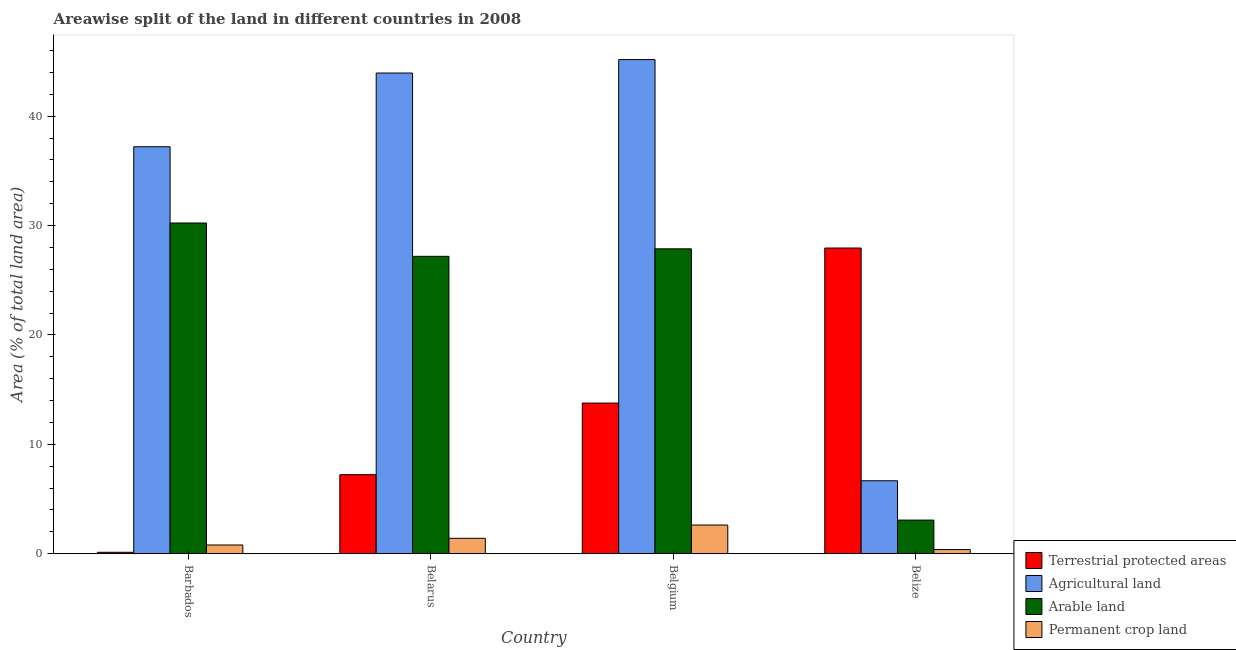How many groups of bars are there?
Ensure brevity in your answer.  4. How many bars are there on the 2nd tick from the left?
Ensure brevity in your answer.  4. How many bars are there on the 3rd tick from the right?
Provide a succinct answer. 4. What is the label of the 2nd group of bars from the left?
Provide a short and direct response. Belarus. What is the percentage of area under permanent crop land in Belize?
Offer a very short reply. 0.38. Across all countries, what is the maximum percentage of land under terrestrial protection?
Keep it short and to the point. 27.95. Across all countries, what is the minimum percentage of land under terrestrial protection?
Ensure brevity in your answer.  0.12. In which country was the percentage of area under arable land maximum?
Your answer should be compact. Barbados. In which country was the percentage of area under agricultural land minimum?
Your answer should be compact. Belize. What is the total percentage of land under terrestrial protection in the graph?
Provide a succinct answer. 49.06. What is the difference between the percentage of area under agricultural land in Belarus and that in Belize?
Provide a succinct answer. 37.28. What is the difference between the percentage of area under agricultural land in Belarus and the percentage of area under permanent crop land in Belgium?
Keep it short and to the point. 41.33. What is the average percentage of area under arable land per country?
Keep it short and to the point. 22.09. What is the difference between the percentage of area under arable land and percentage of land under terrestrial protection in Belarus?
Make the answer very short. 19.96. What is the ratio of the percentage of area under arable land in Belgium to that in Belize?
Your answer should be very brief. 9.08. What is the difference between the highest and the second highest percentage of area under agricultural land?
Provide a short and direct response. 1.23. What is the difference between the highest and the lowest percentage of area under arable land?
Keep it short and to the point. 27.16. In how many countries, is the percentage of area under agricultural land greater than the average percentage of area under agricultural land taken over all countries?
Offer a terse response. 3. Is the sum of the percentage of area under arable land in Belgium and Belize greater than the maximum percentage of land under terrestrial protection across all countries?
Your answer should be compact. Yes. What does the 3rd bar from the left in Barbados represents?
Provide a succinct answer. Arable land. What does the 3rd bar from the right in Belize represents?
Your answer should be very brief. Agricultural land. Is it the case that in every country, the sum of the percentage of land under terrestrial protection and percentage of area under agricultural land is greater than the percentage of area under arable land?
Provide a short and direct response. Yes. Are all the bars in the graph horizontal?
Ensure brevity in your answer.  No. How many countries are there in the graph?
Give a very brief answer. 4. What is the difference between two consecutive major ticks on the Y-axis?
Offer a very short reply. 10. Does the graph contain any zero values?
Offer a very short reply. No. Does the graph contain grids?
Provide a succinct answer. No. Where does the legend appear in the graph?
Keep it short and to the point. Bottom right. How many legend labels are there?
Offer a terse response. 4. What is the title of the graph?
Provide a succinct answer. Areawise split of the land in different countries in 2008. Does "Minerals" appear as one of the legend labels in the graph?
Provide a succinct answer. No. What is the label or title of the X-axis?
Keep it short and to the point. Country. What is the label or title of the Y-axis?
Offer a terse response. Area (% of total land area). What is the Area (% of total land area) in Terrestrial protected areas in Barbados?
Your answer should be very brief. 0.12. What is the Area (% of total land area) in Agricultural land in Barbados?
Provide a succinct answer. 37.21. What is the Area (% of total land area) of Arable land in Barbados?
Give a very brief answer. 30.23. What is the Area (% of total land area) in Permanent crop land in Barbados?
Provide a short and direct response. 0.79. What is the Area (% of total land area) in Terrestrial protected areas in Belarus?
Ensure brevity in your answer.  7.22. What is the Area (% of total land area) in Agricultural land in Belarus?
Give a very brief answer. 43.95. What is the Area (% of total land area) in Arable land in Belarus?
Keep it short and to the point. 27.19. What is the Area (% of total land area) of Permanent crop land in Belarus?
Provide a succinct answer. 1.4. What is the Area (% of total land area) in Terrestrial protected areas in Belgium?
Provide a succinct answer. 13.77. What is the Area (% of total land area) of Agricultural land in Belgium?
Make the answer very short. 45.18. What is the Area (% of total land area) in Arable land in Belgium?
Provide a short and direct response. 27.87. What is the Area (% of total land area) of Permanent crop land in Belgium?
Provide a succinct answer. 2.62. What is the Area (% of total land area) of Terrestrial protected areas in Belize?
Offer a very short reply. 27.95. What is the Area (% of total land area) in Agricultural land in Belize?
Ensure brevity in your answer.  6.66. What is the Area (% of total land area) of Arable land in Belize?
Keep it short and to the point. 3.07. What is the Area (% of total land area) in Permanent crop land in Belize?
Your answer should be compact. 0.38. Across all countries, what is the maximum Area (% of total land area) of Terrestrial protected areas?
Offer a very short reply. 27.95. Across all countries, what is the maximum Area (% of total land area) of Agricultural land?
Your answer should be compact. 45.18. Across all countries, what is the maximum Area (% of total land area) of Arable land?
Offer a terse response. 30.23. Across all countries, what is the maximum Area (% of total land area) in Permanent crop land?
Your response must be concise. 2.62. Across all countries, what is the minimum Area (% of total land area) of Terrestrial protected areas?
Provide a succinct answer. 0.12. Across all countries, what is the minimum Area (% of total land area) in Agricultural land?
Offer a terse response. 6.66. Across all countries, what is the minimum Area (% of total land area) in Arable land?
Offer a very short reply. 3.07. Across all countries, what is the minimum Area (% of total land area) in Permanent crop land?
Provide a succinct answer. 0.38. What is the total Area (% of total land area) of Terrestrial protected areas in the graph?
Your answer should be compact. 49.06. What is the total Area (% of total land area) of Agricultural land in the graph?
Your answer should be very brief. 133. What is the total Area (% of total land area) in Arable land in the graph?
Your response must be concise. 88.36. What is the total Area (% of total land area) of Permanent crop land in the graph?
Offer a terse response. 5.19. What is the difference between the Area (% of total land area) in Terrestrial protected areas in Barbados and that in Belarus?
Your answer should be compact. -7.1. What is the difference between the Area (% of total land area) in Agricultural land in Barbados and that in Belarus?
Offer a terse response. -6.74. What is the difference between the Area (% of total land area) of Arable land in Barbados and that in Belarus?
Your answer should be compact. 3.05. What is the difference between the Area (% of total land area) of Permanent crop land in Barbados and that in Belarus?
Your answer should be very brief. -0.61. What is the difference between the Area (% of total land area) of Terrestrial protected areas in Barbados and that in Belgium?
Your answer should be compact. -13.65. What is the difference between the Area (% of total land area) of Agricultural land in Barbados and that in Belgium?
Your answer should be very brief. -7.97. What is the difference between the Area (% of total land area) of Arable land in Barbados and that in Belgium?
Offer a very short reply. 2.36. What is the difference between the Area (% of total land area) in Permanent crop land in Barbados and that in Belgium?
Provide a short and direct response. -1.82. What is the difference between the Area (% of total land area) of Terrestrial protected areas in Barbados and that in Belize?
Keep it short and to the point. -27.82. What is the difference between the Area (% of total land area) of Agricultural land in Barbados and that in Belize?
Provide a succinct answer. 30.55. What is the difference between the Area (% of total land area) in Arable land in Barbados and that in Belize?
Keep it short and to the point. 27.16. What is the difference between the Area (% of total land area) of Permanent crop land in Barbados and that in Belize?
Your answer should be very brief. 0.42. What is the difference between the Area (% of total land area) of Terrestrial protected areas in Belarus and that in Belgium?
Keep it short and to the point. -6.55. What is the difference between the Area (% of total land area) of Agricultural land in Belarus and that in Belgium?
Your answer should be very brief. -1.23. What is the difference between the Area (% of total land area) of Arable land in Belarus and that in Belgium?
Your answer should be compact. -0.69. What is the difference between the Area (% of total land area) in Permanent crop land in Belarus and that in Belgium?
Offer a terse response. -1.21. What is the difference between the Area (% of total land area) of Terrestrial protected areas in Belarus and that in Belize?
Offer a very short reply. -20.72. What is the difference between the Area (% of total land area) in Agricultural land in Belarus and that in Belize?
Keep it short and to the point. 37.28. What is the difference between the Area (% of total land area) of Arable land in Belarus and that in Belize?
Your answer should be very brief. 24.12. What is the difference between the Area (% of total land area) in Permanent crop land in Belarus and that in Belize?
Make the answer very short. 1.03. What is the difference between the Area (% of total land area) of Terrestrial protected areas in Belgium and that in Belize?
Give a very brief answer. -14.18. What is the difference between the Area (% of total land area) in Agricultural land in Belgium and that in Belize?
Make the answer very short. 38.51. What is the difference between the Area (% of total land area) of Arable land in Belgium and that in Belize?
Provide a short and direct response. 24.8. What is the difference between the Area (% of total land area) in Permanent crop land in Belgium and that in Belize?
Provide a short and direct response. 2.24. What is the difference between the Area (% of total land area) in Terrestrial protected areas in Barbados and the Area (% of total land area) in Agricultural land in Belarus?
Offer a very short reply. -43.82. What is the difference between the Area (% of total land area) of Terrestrial protected areas in Barbados and the Area (% of total land area) of Arable land in Belarus?
Make the answer very short. -27.06. What is the difference between the Area (% of total land area) of Terrestrial protected areas in Barbados and the Area (% of total land area) of Permanent crop land in Belarus?
Make the answer very short. -1.28. What is the difference between the Area (% of total land area) in Agricultural land in Barbados and the Area (% of total land area) in Arable land in Belarus?
Make the answer very short. 10.02. What is the difference between the Area (% of total land area) of Agricultural land in Barbados and the Area (% of total land area) of Permanent crop land in Belarus?
Keep it short and to the point. 35.81. What is the difference between the Area (% of total land area) in Arable land in Barbados and the Area (% of total land area) in Permanent crop land in Belarus?
Offer a very short reply. 28.83. What is the difference between the Area (% of total land area) in Terrestrial protected areas in Barbados and the Area (% of total land area) in Agricultural land in Belgium?
Make the answer very short. -45.05. What is the difference between the Area (% of total land area) of Terrestrial protected areas in Barbados and the Area (% of total land area) of Arable land in Belgium?
Give a very brief answer. -27.75. What is the difference between the Area (% of total land area) in Terrestrial protected areas in Barbados and the Area (% of total land area) in Permanent crop land in Belgium?
Your response must be concise. -2.49. What is the difference between the Area (% of total land area) in Agricultural land in Barbados and the Area (% of total land area) in Arable land in Belgium?
Provide a succinct answer. 9.34. What is the difference between the Area (% of total land area) in Agricultural land in Barbados and the Area (% of total land area) in Permanent crop land in Belgium?
Provide a short and direct response. 34.59. What is the difference between the Area (% of total land area) of Arable land in Barbados and the Area (% of total land area) of Permanent crop land in Belgium?
Offer a very short reply. 27.62. What is the difference between the Area (% of total land area) in Terrestrial protected areas in Barbados and the Area (% of total land area) in Agricultural land in Belize?
Make the answer very short. -6.54. What is the difference between the Area (% of total land area) of Terrestrial protected areas in Barbados and the Area (% of total land area) of Arable land in Belize?
Offer a terse response. -2.94. What is the difference between the Area (% of total land area) of Terrestrial protected areas in Barbados and the Area (% of total land area) of Permanent crop land in Belize?
Your answer should be compact. -0.25. What is the difference between the Area (% of total land area) of Agricultural land in Barbados and the Area (% of total land area) of Arable land in Belize?
Give a very brief answer. 34.14. What is the difference between the Area (% of total land area) of Agricultural land in Barbados and the Area (% of total land area) of Permanent crop land in Belize?
Offer a terse response. 36.83. What is the difference between the Area (% of total land area) in Arable land in Barbados and the Area (% of total land area) in Permanent crop land in Belize?
Ensure brevity in your answer.  29.86. What is the difference between the Area (% of total land area) of Terrestrial protected areas in Belarus and the Area (% of total land area) of Agricultural land in Belgium?
Offer a terse response. -37.96. What is the difference between the Area (% of total land area) in Terrestrial protected areas in Belarus and the Area (% of total land area) in Arable land in Belgium?
Provide a succinct answer. -20.65. What is the difference between the Area (% of total land area) of Terrestrial protected areas in Belarus and the Area (% of total land area) of Permanent crop land in Belgium?
Give a very brief answer. 4.61. What is the difference between the Area (% of total land area) in Agricultural land in Belarus and the Area (% of total land area) in Arable land in Belgium?
Offer a terse response. 16.07. What is the difference between the Area (% of total land area) of Agricultural land in Belarus and the Area (% of total land area) of Permanent crop land in Belgium?
Offer a terse response. 41.33. What is the difference between the Area (% of total land area) of Arable land in Belarus and the Area (% of total land area) of Permanent crop land in Belgium?
Ensure brevity in your answer.  24.57. What is the difference between the Area (% of total land area) of Terrestrial protected areas in Belarus and the Area (% of total land area) of Agricultural land in Belize?
Keep it short and to the point. 0.56. What is the difference between the Area (% of total land area) of Terrestrial protected areas in Belarus and the Area (% of total land area) of Arable land in Belize?
Ensure brevity in your answer.  4.15. What is the difference between the Area (% of total land area) of Terrestrial protected areas in Belarus and the Area (% of total land area) of Permanent crop land in Belize?
Offer a terse response. 6.85. What is the difference between the Area (% of total land area) in Agricultural land in Belarus and the Area (% of total land area) in Arable land in Belize?
Keep it short and to the point. 40.88. What is the difference between the Area (% of total land area) of Agricultural land in Belarus and the Area (% of total land area) of Permanent crop land in Belize?
Your answer should be very brief. 43.57. What is the difference between the Area (% of total land area) of Arable land in Belarus and the Area (% of total land area) of Permanent crop land in Belize?
Keep it short and to the point. 26.81. What is the difference between the Area (% of total land area) in Terrestrial protected areas in Belgium and the Area (% of total land area) in Agricultural land in Belize?
Ensure brevity in your answer.  7.11. What is the difference between the Area (% of total land area) in Terrestrial protected areas in Belgium and the Area (% of total land area) in Arable land in Belize?
Keep it short and to the point. 10.7. What is the difference between the Area (% of total land area) of Terrestrial protected areas in Belgium and the Area (% of total land area) of Permanent crop land in Belize?
Offer a very short reply. 13.39. What is the difference between the Area (% of total land area) of Agricultural land in Belgium and the Area (% of total land area) of Arable land in Belize?
Your response must be concise. 42.11. What is the difference between the Area (% of total land area) in Agricultural land in Belgium and the Area (% of total land area) in Permanent crop land in Belize?
Provide a short and direct response. 44.8. What is the difference between the Area (% of total land area) in Arable land in Belgium and the Area (% of total land area) in Permanent crop land in Belize?
Offer a very short reply. 27.5. What is the average Area (% of total land area) of Terrestrial protected areas per country?
Keep it short and to the point. 12.27. What is the average Area (% of total land area) of Agricultural land per country?
Ensure brevity in your answer.  33.25. What is the average Area (% of total land area) of Arable land per country?
Your answer should be compact. 22.09. What is the average Area (% of total land area) in Permanent crop land per country?
Keep it short and to the point. 1.3. What is the difference between the Area (% of total land area) in Terrestrial protected areas and Area (% of total land area) in Agricultural land in Barbados?
Your answer should be very brief. -37.09. What is the difference between the Area (% of total land area) in Terrestrial protected areas and Area (% of total land area) in Arable land in Barbados?
Provide a short and direct response. -30.11. What is the difference between the Area (% of total land area) in Terrestrial protected areas and Area (% of total land area) in Permanent crop land in Barbados?
Make the answer very short. -0.67. What is the difference between the Area (% of total land area) of Agricultural land and Area (% of total land area) of Arable land in Barbados?
Provide a succinct answer. 6.98. What is the difference between the Area (% of total land area) in Agricultural land and Area (% of total land area) in Permanent crop land in Barbados?
Keep it short and to the point. 36.42. What is the difference between the Area (% of total land area) of Arable land and Area (% of total land area) of Permanent crop land in Barbados?
Offer a terse response. 29.44. What is the difference between the Area (% of total land area) in Terrestrial protected areas and Area (% of total land area) in Agricultural land in Belarus?
Provide a short and direct response. -36.73. What is the difference between the Area (% of total land area) in Terrestrial protected areas and Area (% of total land area) in Arable land in Belarus?
Provide a succinct answer. -19.96. What is the difference between the Area (% of total land area) in Terrestrial protected areas and Area (% of total land area) in Permanent crop land in Belarus?
Keep it short and to the point. 5.82. What is the difference between the Area (% of total land area) of Agricultural land and Area (% of total land area) of Arable land in Belarus?
Provide a succinct answer. 16.76. What is the difference between the Area (% of total land area) in Agricultural land and Area (% of total land area) in Permanent crop land in Belarus?
Give a very brief answer. 42.54. What is the difference between the Area (% of total land area) of Arable land and Area (% of total land area) of Permanent crop land in Belarus?
Provide a short and direct response. 25.78. What is the difference between the Area (% of total land area) of Terrestrial protected areas and Area (% of total land area) of Agricultural land in Belgium?
Offer a very short reply. -31.41. What is the difference between the Area (% of total land area) of Terrestrial protected areas and Area (% of total land area) of Arable land in Belgium?
Provide a succinct answer. -14.1. What is the difference between the Area (% of total land area) in Terrestrial protected areas and Area (% of total land area) in Permanent crop land in Belgium?
Your answer should be very brief. 11.15. What is the difference between the Area (% of total land area) in Agricultural land and Area (% of total land area) in Arable land in Belgium?
Offer a very short reply. 17.31. What is the difference between the Area (% of total land area) in Agricultural land and Area (% of total land area) in Permanent crop land in Belgium?
Keep it short and to the point. 42.56. What is the difference between the Area (% of total land area) of Arable land and Area (% of total land area) of Permanent crop land in Belgium?
Your answer should be very brief. 25.26. What is the difference between the Area (% of total land area) in Terrestrial protected areas and Area (% of total land area) in Agricultural land in Belize?
Offer a very short reply. 21.28. What is the difference between the Area (% of total land area) in Terrestrial protected areas and Area (% of total land area) in Arable land in Belize?
Offer a terse response. 24.88. What is the difference between the Area (% of total land area) of Terrestrial protected areas and Area (% of total land area) of Permanent crop land in Belize?
Keep it short and to the point. 27.57. What is the difference between the Area (% of total land area) in Agricultural land and Area (% of total land area) in Arable land in Belize?
Make the answer very short. 3.59. What is the difference between the Area (% of total land area) in Agricultural land and Area (% of total land area) in Permanent crop land in Belize?
Offer a terse response. 6.29. What is the difference between the Area (% of total land area) in Arable land and Area (% of total land area) in Permanent crop land in Belize?
Ensure brevity in your answer.  2.69. What is the ratio of the Area (% of total land area) of Terrestrial protected areas in Barbados to that in Belarus?
Keep it short and to the point. 0.02. What is the ratio of the Area (% of total land area) in Agricultural land in Barbados to that in Belarus?
Provide a short and direct response. 0.85. What is the ratio of the Area (% of total land area) in Arable land in Barbados to that in Belarus?
Provide a short and direct response. 1.11. What is the ratio of the Area (% of total land area) in Permanent crop land in Barbados to that in Belarus?
Offer a terse response. 0.56. What is the ratio of the Area (% of total land area) of Terrestrial protected areas in Barbados to that in Belgium?
Offer a very short reply. 0.01. What is the ratio of the Area (% of total land area) of Agricultural land in Barbados to that in Belgium?
Keep it short and to the point. 0.82. What is the ratio of the Area (% of total land area) in Arable land in Barbados to that in Belgium?
Your response must be concise. 1.08. What is the ratio of the Area (% of total land area) of Permanent crop land in Barbados to that in Belgium?
Ensure brevity in your answer.  0.3. What is the ratio of the Area (% of total land area) of Terrestrial protected areas in Barbados to that in Belize?
Provide a succinct answer. 0. What is the ratio of the Area (% of total land area) of Agricultural land in Barbados to that in Belize?
Offer a terse response. 5.58. What is the ratio of the Area (% of total land area) in Arable land in Barbados to that in Belize?
Your answer should be very brief. 9.85. What is the ratio of the Area (% of total land area) of Permanent crop land in Barbados to that in Belize?
Your answer should be very brief. 2.11. What is the ratio of the Area (% of total land area) of Terrestrial protected areas in Belarus to that in Belgium?
Provide a succinct answer. 0.52. What is the ratio of the Area (% of total land area) of Agricultural land in Belarus to that in Belgium?
Your response must be concise. 0.97. What is the ratio of the Area (% of total land area) of Arable land in Belarus to that in Belgium?
Your response must be concise. 0.98. What is the ratio of the Area (% of total land area) in Permanent crop land in Belarus to that in Belgium?
Offer a terse response. 0.54. What is the ratio of the Area (% of total land area) of Terrestrial protected areas in Belarus to that in Belize?
Give a very brief answer. 0.26. What is the ratio of the Area (% of total land area) in Agricultural land in Belarus to that in Belize?
Make the answer very short. 6.6. What is the ratio of the Area (% of total land area) of Arable land in Belarus to that in Belize?
Your answer should be very brief. 8.86. What is the ratio of the Area (% of total land area) in Permanent crop land in Belarus to that in Belize?
Your answer should be very brief. 3.74. What is the ratio of the Area (% of total land area) in Terrestrial protected areas in Belgium to that in Belize?
Provide a short and direct response. 0.49. What is the ratio of the Area (% of total land area) of Agricultural land in Belgium to that in Belize?
Offer a terse response. 6.78. What is the ratio of the Area (% of total land area) in Arable land in Belgium to that in Belize?
Give a very brief answer. 9.08. What is the ratio of the Area (% of total land area) of Permanent crop land in Belgium to that in Belize?
Make the answer very short. 6.97. What is the difference between the highest and the second highest Area (% of total land area) in Terrestrial protected areas?
Provide a succinct answer. 14.18. What is the difference between the highest and the second highest Area (% of total land area) in Agricultural land?
Keep it short and to the point. 1.23. What is the difference between the highest and the second highest Area (% of total land area) in Arable land?
Provide a short and direct response. 2.36. What is the difference between the highest and the second highest Area (% of total land area) of Permanent crop land?
Your response must be concise. 1.21. What is the difference between the highest and the lowest Area (% of total land area) in Terrestrial protected areas?
Your answer should be compact. 27.82. What is the difference between the highest and the lowest Area (% of total land area) of Agricultural land?
Give a very brief answer. 38.51. What is the difference between the highest and the lowest Area (% of total land area) in Arable land?
Provide a short and direct response. 27.16. What is the difference between the highest and the lowest Area (% of total land area) of Permanent crop land?
Offer a terse response. 2.24. 